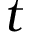<formula> <loc_0><loc_0><loc_500><loc_500>t</formula> 